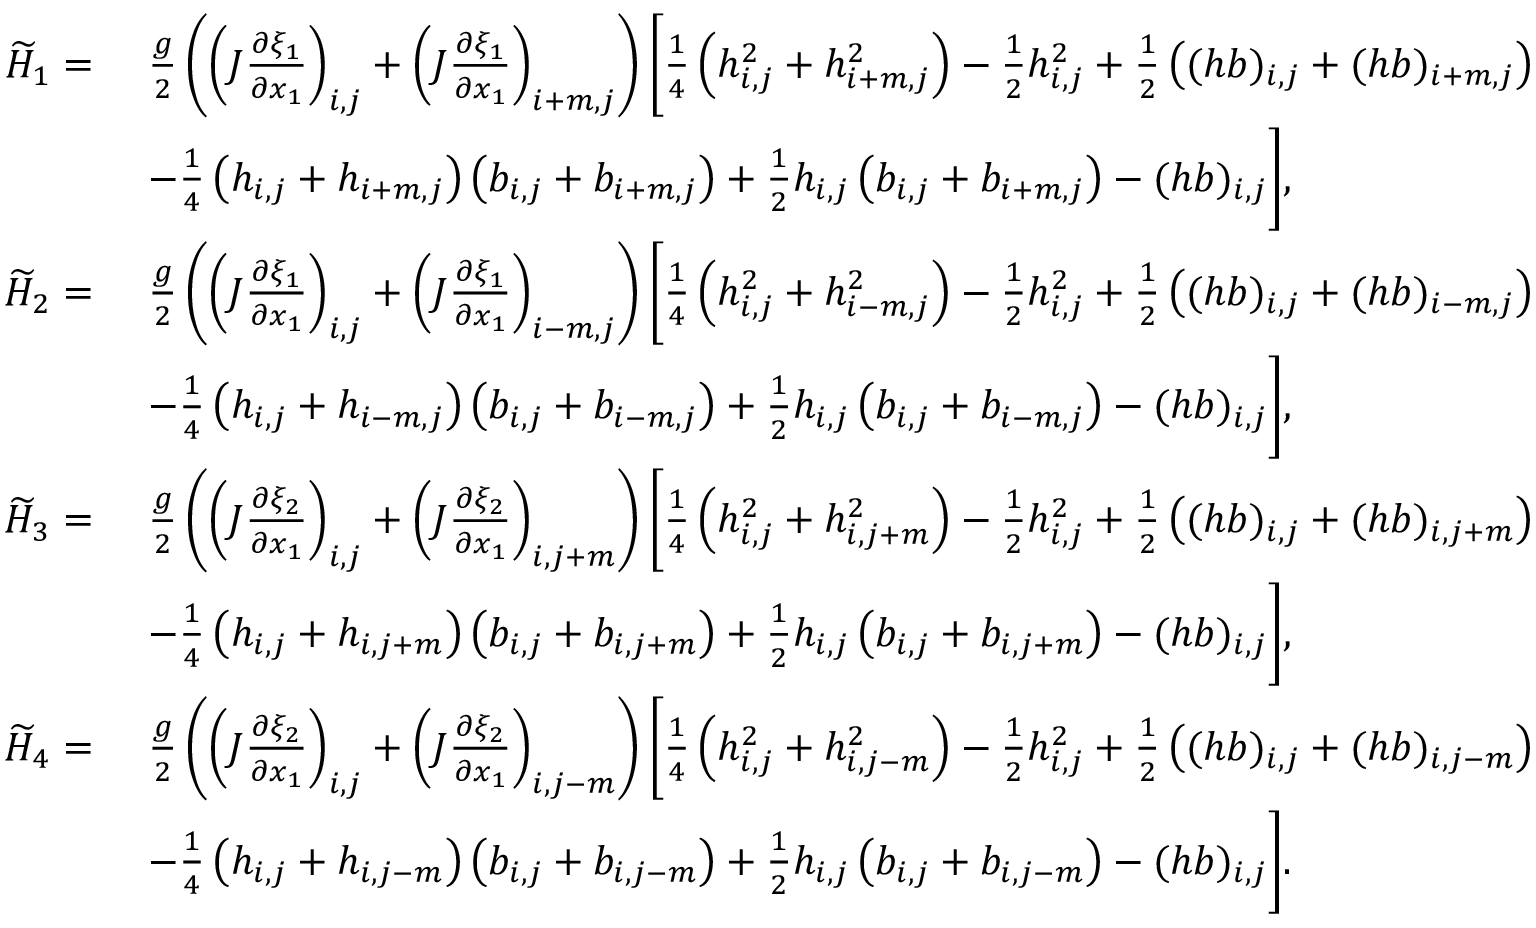<formula> <loc_0><loc_0><loc_500><loc_500>\begin{array} { r l } { \widetilde { H } _ { 1 } = \ } & { \frac { g } { 2 } \left ( \left ( J \frac { \partial \xi _ { 1 } } { \partial x _ { 1 } } \right ) _ { i , j } + \left ( J \frac { \partial \xi _ { 1 } } { \partial x _ { 1 } } \right ) _ { i + m , j } \right ) \left [ \frac { 1 } { 4 } \left ( h _ { i , j } ^ { 2 } + h _ { i + m , j } ^ { 2 } \right ) - \frac { 1 } { 2 } h _ { i , j } ^ { 2 } + \frac { 1 } { 2 } \left ( ( h b ) _ { i , j } + ( h b ) _ { i + m , j } \right ) } \\ & { - \frac { 1 } { 4 } \left ( { h } _ { i , j } + { h } _ { i + m , j } \right ) \left ( { b } _ { i , j } + { b } _ { i + m , j } \right ) + \frac { 1 } { 2 } h _ { i , j } \left ( { b } _ { i , j } + { b } _ { i + m , j } \right ) - ( h b ) _ { i , j } \right ] , } \\ { \widetilde { H } _ { 2 } = \ } & { \frac { g } { 2 } \left ( \left ( J \frac { \partial \xi _ { 1 } } { \partial x _ { 1 } } \right ) _ { i , j } + \left ( J \frac { \partial \xi _ { 1 } } { \partial x _ { 1 } } \right ) _ { i - m , j } \right ) \left [ \frac { 1 } { 4 } \left ( h _ { i , j } ^ { 2 } + h _ { i - m , j } ^ { 2 } \right ) - \frac { 1 } { 2 } h _ { i , j } ^ { 2 } + \frac { 1 } { 2 } \left ( ( h b ) _ { i , j } + ( h b ) _ { i - m , j } \right ) } \\ & { - \frac { 1 } { 4 } \left ( { h } _ { i , j } + { h } _ { i - m , j } \right ) \left ( { b } _ { i , j } + { b } _ { i - m , j } \right ) + \frac { 1 } { 2 } h _ { i , j } \left ( { b } _ { i , j } + { b } _ { i - m , j } \right ) - ( h b ) _ { i , j } \right ] , } \\ { \widetilde { H } _ { 3 } = \ } & { \frac { g } { 2 } \left ( \left ( J \frac { \partial \xi _ { 2 } } { \partial x _ { 1 } } \right ) _ { i , j } + \left ( J \frac { \partial \xi _ { 2 } } { \partial x _ { 1 } } \right ) _ { i , j + m } \right ) \left [ \frac { 1 } { 4 } \left ( h _ { i , j } ^ { 2 } + h _ { i , j + m } ^ { 2 } \right ) - \frac { 1 } { 2 } h _ { i , j } ^ { 2 } + \frac { 1 } { 2 } \left ( ( h b ) _ { i , j } + ( h b ) _ { i , j + m } \right ) } \\ & { - \frac { 1 } { 4 } \left ( { h } _ { i , j } + { h } _ { i , j + m } \right ) \left ( { b } _ { i , j } + { b } _ { i , j + m } \right ) + \frac { 1 } { 2 } h _ { i , j } \left ( { b } _ { i , j } + { b } _ { i , j + m } \right ) - ( h b ) _ { i , j } \right ] , } \\ { \widetilde { H } _ { 4 } = \ } & { \frac { g } { 2 } \left ( \left ( J \frac { \partial \xi _ { 2 } } { \partial x _ { 1 } } \right ) _ { i , j } + \left ( J \frac { \partial \xi _ { 2 } } { \partial x _ { 1 } } \right ) _ { i , j - m } \right ) \left [ \frac { 1 } { 4 } \left ( h _ { i , j } ^ { 2 } + h _ { i , j - m } ^ { 2 } \right ) - \frac { 1 } { 2 } h _ { i , j } ^ { 2 } + \frac { 1 } { 2 } \left ( ( h b ) _ { i , j } + ( h b ) _ { i , j - m } \right ) } \\ & { - \frac { 1 } { 4 } \left ( { h } _ { i , j } + { h } _ { i , j - m } \right ) \left ( { b } _ { i , j } + { b } _ { i , j - m } \right ) + \frac { 1 } { 2 } h _ { i , j } \left ( { b } _ { i , j } + { b } _ { i , j - m } \right ) - ( h b ) _ { i , j } \right ] . } \end{array}</formula> 